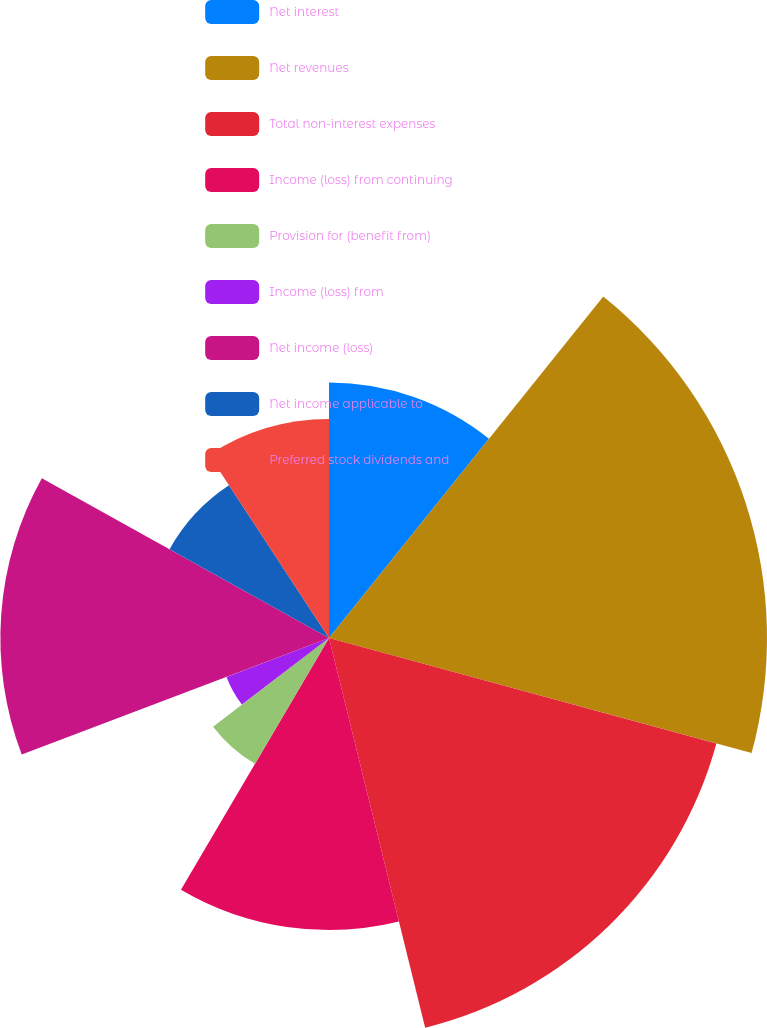<chart> <loc_0><loc_0><loc_500><loc_500><pie_chart><fcel>Net interest<fcel>Net revenues<fcel>Total non-interest expenses<fcel>Income (loss) from continuing<fcel>Provision for (benefit from)<fcel>Income (loss) from<fcel>Net income (loss)<fcel>Net income applicable to<fcel>Preferred stock dividends and<nl><fcel>10.77%<fcel>18.46%<fcel>16.92%<fcel>12.31%<fcel>6.15%<fcel>4.62%<fcel>13.85%<fcel>7.69%<fcel>9.23%<nl></chart> 